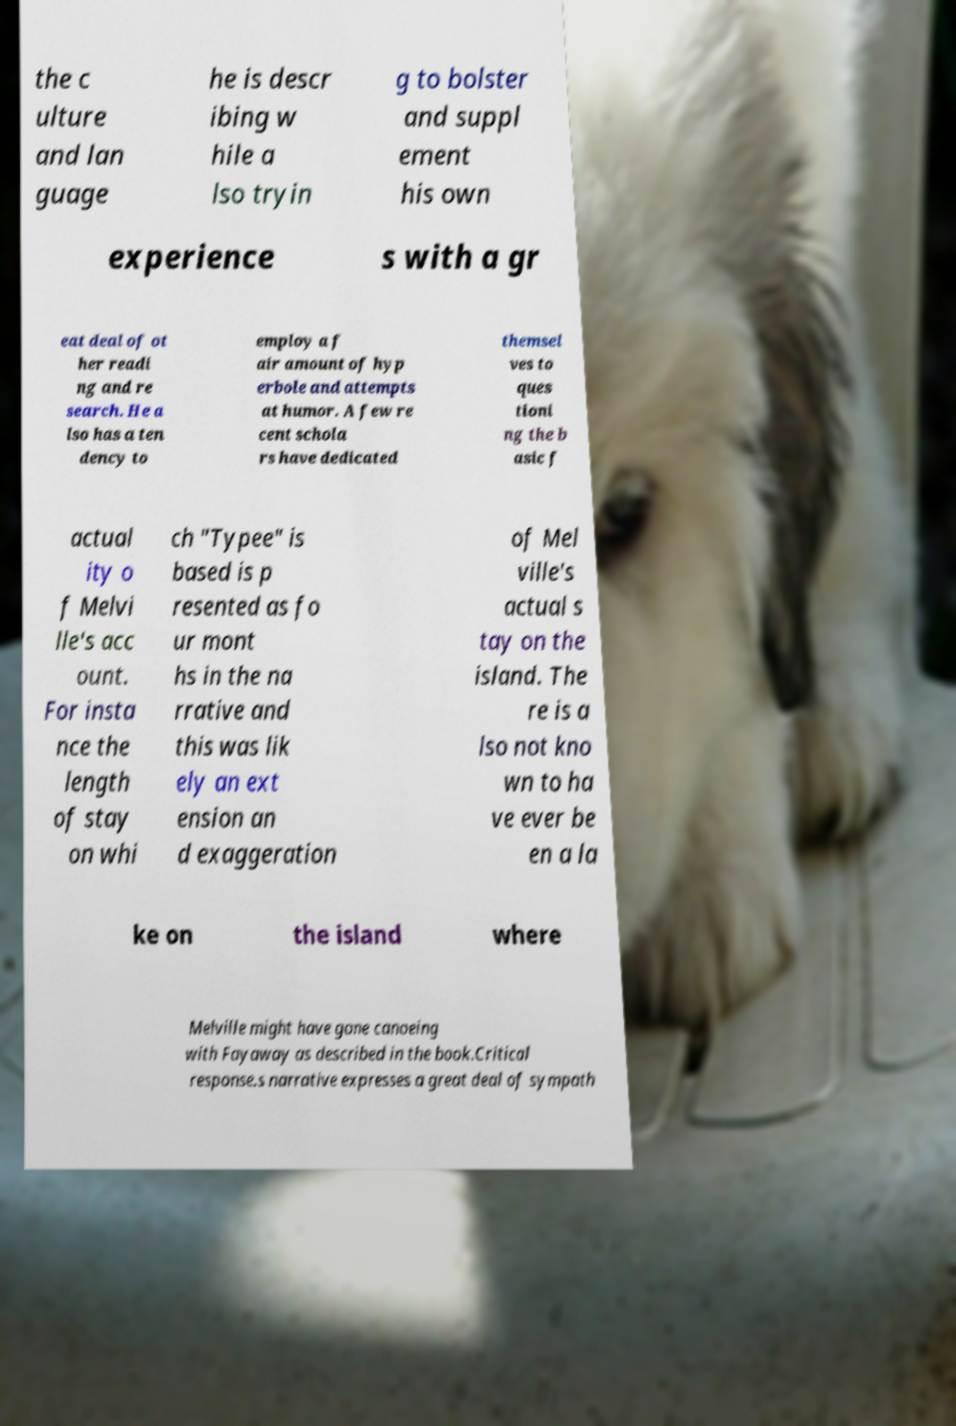For documentation purposes, I need the text within this image transcribed. Could you provide that? the c ulture and lan guage he is descr ibing w hile a lso tryin g to bolster and suppl ement his own experience s with a gr eat deal of ot her readi ng and re search. He a lso has a ten dency to employ a f air amount of hyp erbole and attempts at humor. A few re cent schola rs have dedicated themsel ves to ques tioni ng the b asic f actual ity o f Melvi lle's acc ount. For insta nce the length of stay on whi ch "Typee" is based is p resented as fo ur mont hs in the na rrative and this was lik ely an ext ension an d exaggeration of Mel ville's actual s tay on the island. The re is a lso not kno wn to ha ve ever be en a la ke on the island where Melville might have gone canoeing with Fayaway as described in the book.Critical response.s narrative expresses a great deal of sympath 